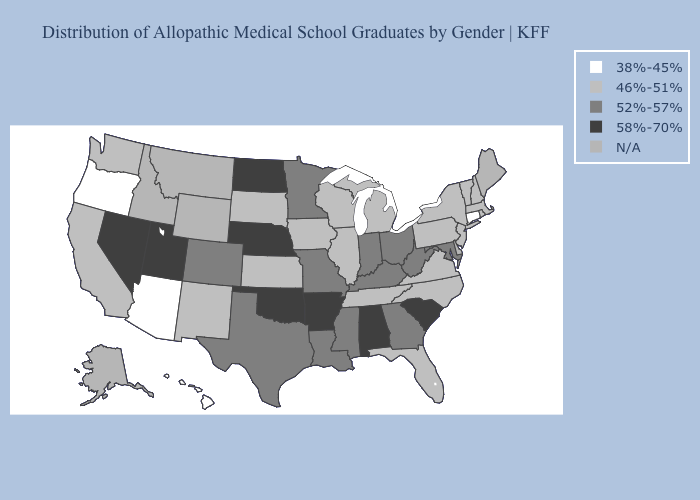What is the value of Georgia?
Keep it brief. 52%-57%. Does Connecticut have the lowest value in the Northeast?
Quick response, please. Yes. What is the highest value in the USA?
Write a very short answer. 58%-70%. Among the states that border Louisiana , which have the highest value?
Quick response, please. Arkansas. What is the lowest value in the Northeast?
Keep it brief. 38%-45%. What is the value of Arkansas?
Quick response, please. 58%-70%. Among the states that border Wyoming , which have the lowest value?
Keep it brief. South Dakota. Name the states that have a value in the range 52%-57%?
Keep it brief. Colorado, Georgia, Indiana, Kentucky, Louisiana, Maryland, Minnesota, Mississippi, Missouri, Ohio, Texas, West Virginia. What is the value of Illinois?
Short answer required. 46%-51%. Name the states that have a value in the range N/A?
Write a very short answer. Alaska, Delaware, Idaho, Maine, Montana, Wyoming. Does Connecticut have the lowest value in the USA?
Be succinct. Yes. Name the states that have a value in the range 46%-51%?
Answer briefly. California, Florida, Illinois, Iowa, Kansas, Massachusetts, Michigan, New Hampshire, New Jersey, New Mexico, New York, North Carolina, Pennsylvania, Rhode Island, South Dakota, Tennessee, Vermont, Virginia, Washington, Wisconsin. Name the states that have a value in the range 38%-45%?
Short answer required. Arizona, Connecticut, Hawaii, Oregon. 